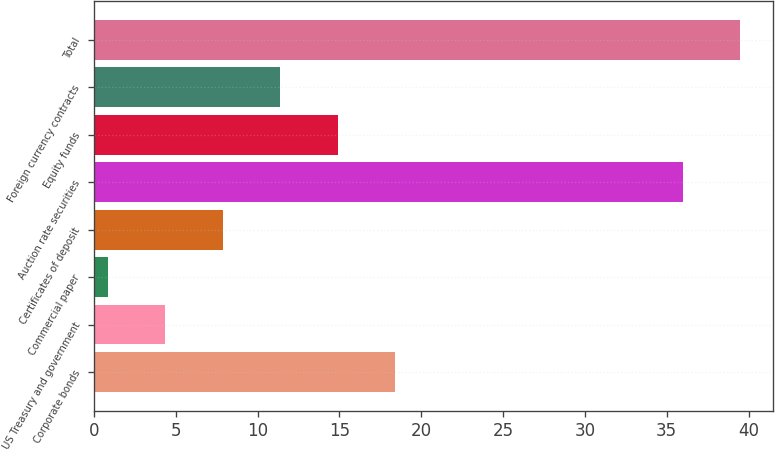Convert chart to OTSL. <chart><loc_0><loc_0><loc_500><loc_500><bar_chart><fcel>Corporate bonds<fcel>US Treasury and government<fcel>Commercial paper<fcel>Certificates of deposit<fcel>Auction rate securities<fcel>Equity funds<fcel>Foreign currency contracts<fcel>Total<nl><fcel>18.41<fcel>4.37<fcel>0.86<fcel>7.88<fcel>36<fcel>14.9<fcel>11.39<fcel>39.51<nl></chart> 